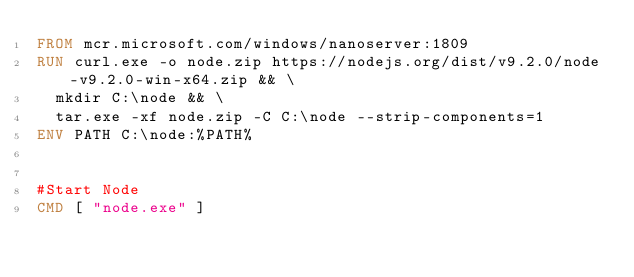<code> <loc_0><loc_0><loc_500><loc_500><_Dockerfile_>FROM mcr.microsoft.com/windows/nanoserver:1809
RUN curl.exe -o node.zip https://nodejs.org/dist/v9.2.0/node-v9.2.0-win-x64.zip && \
  mkdir C:\node && \
  tar.exe -xf node.zip -C C:\node --strip-components=1
ENV PATH C:\node:%PATH%


#Start Node
CMD [ "node.exe" ]
</code> 